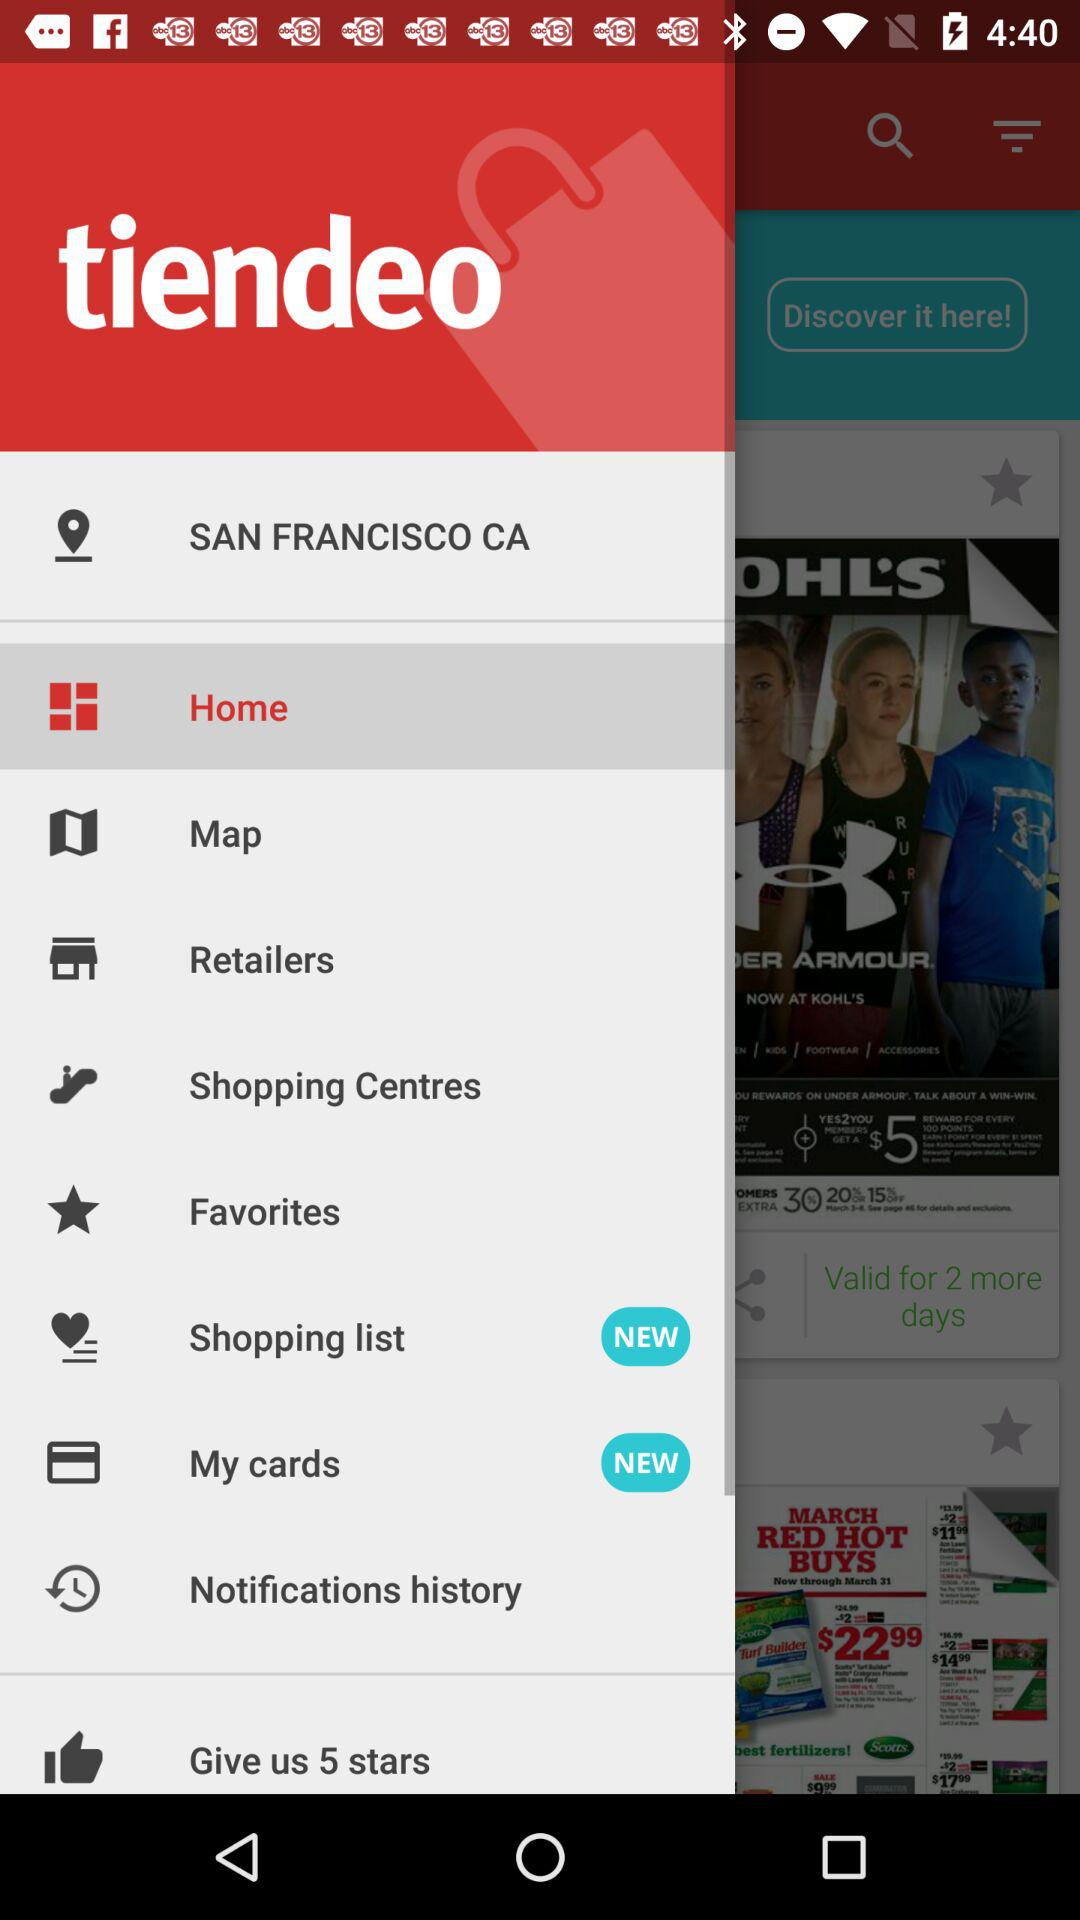What is the location? The location is San Francisco, CA. 